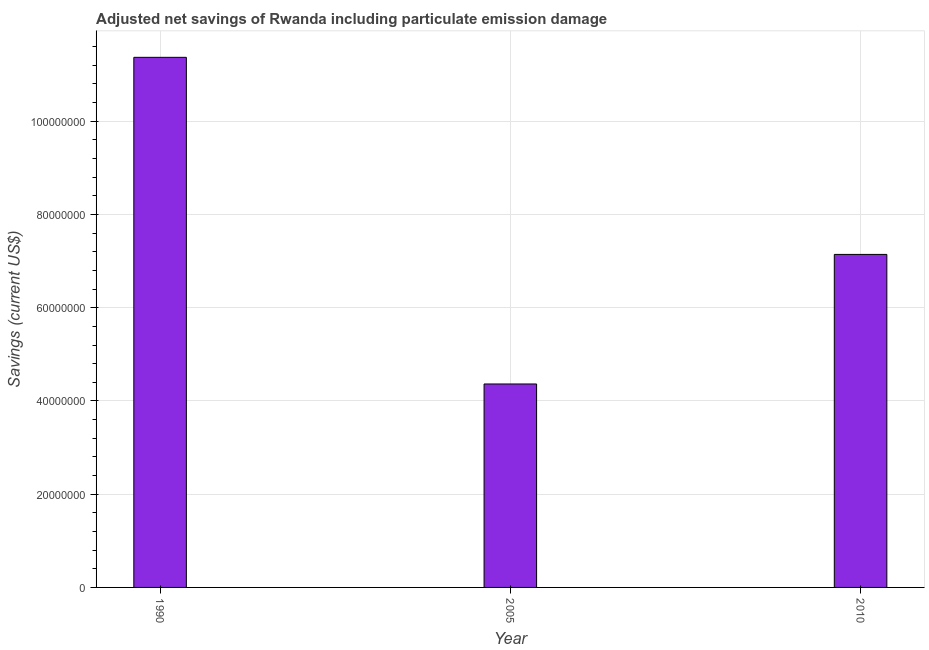Does the graph contain any zero values?
Provide a short and direct response. No. What is the title of the graph?
Give a very brief answer. Adjusted net savings of Rwanda including particulate emission damage. What is the label or title of the X-axis?
Ensure brevity in your answer.  Year. What is the label or title of the Y-axis?
Ensure brevity in your answer.  Savings (current US$). What is the adjusted net savings in 2010?
Offer a very short reply. 7.14e+07. Across all years, what is the maximum adjusted net savings?
Give a very brief answer. 1.14e+08. Across all years, what is the minimum adjusted net savings?
Provide a short and direct response. 4.36e+07. What is the sum of the adjusted net savings?
Your answer should be compact. 2.29e+08. What is the difference between the adjusted net savings in 1990 and 2005?
Your answer should be very brief. 7.01e+07. What is the average adjusted net savings per year?
Offer a very short reply. 7.63e+07. What is the median adjusted net savings?
Give a very brief answer. 7.14e+07. What is the ratio of the adjusted net savings in 1990 to that in 2005?
Offer a very short reply. 2.61. What is the difference between the highest and the second highest adjusted net savings?
Keep it short and to the point. 4.23e+07. Is the sum of the adjusted net savings in 1990 and 2010 greater than the maximum adjusted net savings across all years?
Provide a short and direct response. Yes. What is the difference between the highest and the lowest adjusted net savings?
Your answer should be compact. 7.01e+07. How many bars are there?
Offer a terse response. 3. How many years are there in the graph?
Ensure brevity in your answer.  3. What is the difference between two consecutive major ticks on the Y-axis?
Offer a very short reply. 2.00e+07. What is the Savings (current US$) in 1990?
Provide a succinct answer. 1.14e+08. What is the Savings (current US$) of 2005?
Offer a very short reply. 4.36e+07. What is the Savings (current US$) in 2010?
Offer a very short reply. 7.14e+07. What is the difference between the Savings (current US$) in 1990 and 2005?
Ensure brevity in your answer.  7.01e+07. What is the difference between the Savings (current US$) in 1990 and 2010?
Provide a succinct answer. 4.23e+07. What is the difference between the Savings (current US$) in 2005 and 2010?
Offer a very short reply. -2.78e+07. What is the ratio of the Savings (current US$) in 1990 to that in 2005?
Offer a very short reply. 2.61. What is the ratio of the Savings (current US$) in 1990 to that in 2010?
Give a very brief answer. 1.59. What is the ratio of the Savings (current US$) in 2005 to that in 2010?
Your answer should be compact. 0.61. 